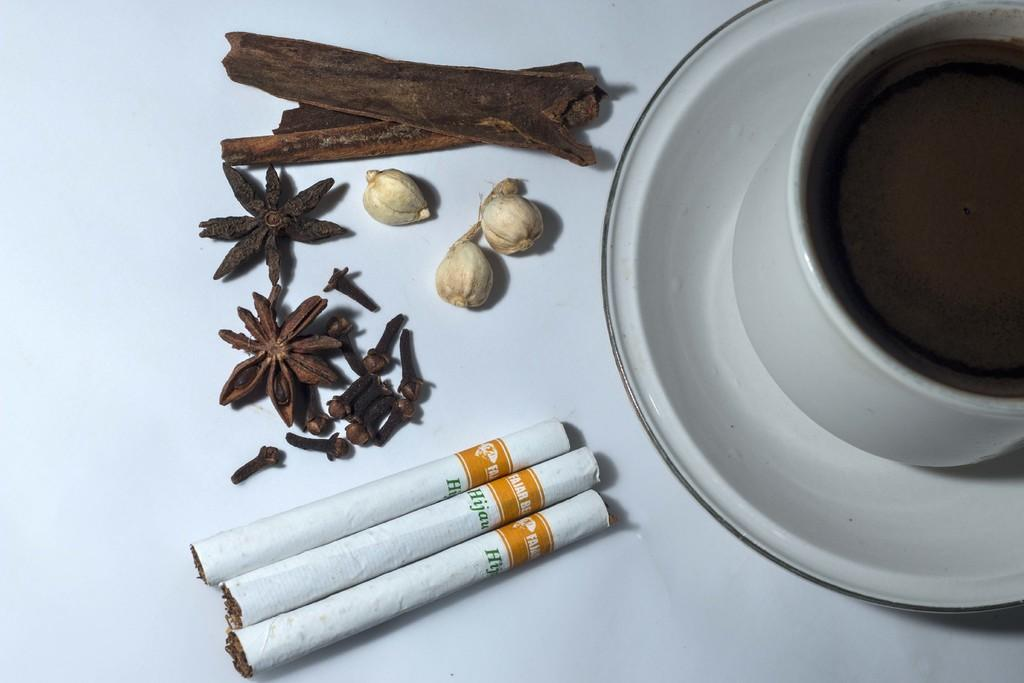What type of product can be seen in the image? There are cigarettes in the image. What is the saucer used for in the image? The saucer is likely used to hold the cup in the image. What is the cup used for in the image? The cup is likely used for holding a beverage or other liquid. What other food items can be seen in the image? There are other food items in the image, but their specific types are not mentioned in the facts. What is the color of the surface the items are placed on? The surface the items are on is white in color. What type of pig is present in the image? There is no pig present in the image. What type of destruction can be seen in the image? There is no destruction present in the image. 